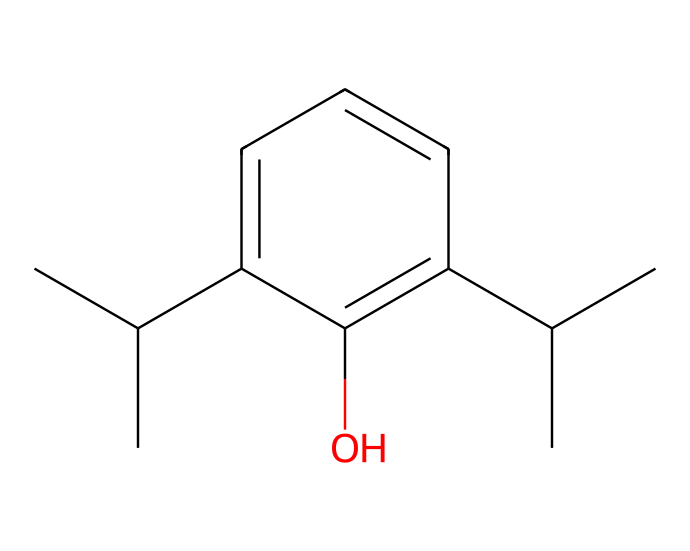What is the molecular formula of this compound? To determine the molecular formula, count the number of each type of atom present in the SMILES representation. The given SMILES indicates there are 15 carbon (C) atoms, 22 hydrogen (H) atoms, and 1 oxygen (O) atom. Therefore, the molecular formula is C15H22O.
Answer: C15H22O How many chiral centers does propofol have? The SMILES structure shows two carbon atoms that have four different substituents. Thus, propofol has two chiral centers.
Answer: 2 What is the main functional group present in propofol? The SMILES representation shows an -OH group, which indicates the presence of an alcohol functional group. This is the main functional group in propofol.
Answer: alcohol Which stereoisomers can be formed from this compound? Given the two chiral centers in propofol, it can theoretically form 2^2 = 4 stereoisomers. This means there are 4 possible configurational isomers due to the arrangement around the chiral centers.
Answer: 4 What type of isomerism does propofol exhibit? Since propofol has chiral centers leading to different stereoisomers, it exhibits stereoisomerism. This is a specific type of isomerism related to the spatial arrangement of atoms.
Answer: stereoisomerism Which part of the compound contributes to its anesthetic properties? The presence of the hydrophobic aromatic ring and the alcohol group contributes to the molecular properties that are essential for its anesthetic effects when interacting with biological membranes and receptors.
Answer: aromatic ring and alcohol group 